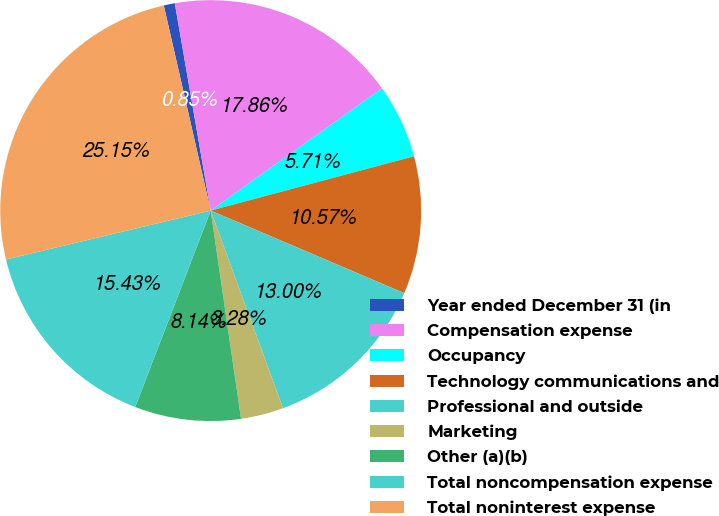Convert chart to OTSL. <chart><loc_0><loc_0><loc_500><loc_500><pie_chart><fcel>Year ended December 31 (in<fcel>Compensation expense<fcel>Occupancy<fcel>Technology communications and<fcel>Professional and outside<fcel>Marketing<fcel>Other (a)(b)<fcel>Total noncompensation expense<fcel>Total noninterest expense<nl><fcel>0.85%<fcel>17.86%<fcel>5.71%<fcel>10.57%<fcel>13.0%<fcel>3.28%<fcel>8.14%<fcel>15.43%<fcel>25.15%<nl></chart> 